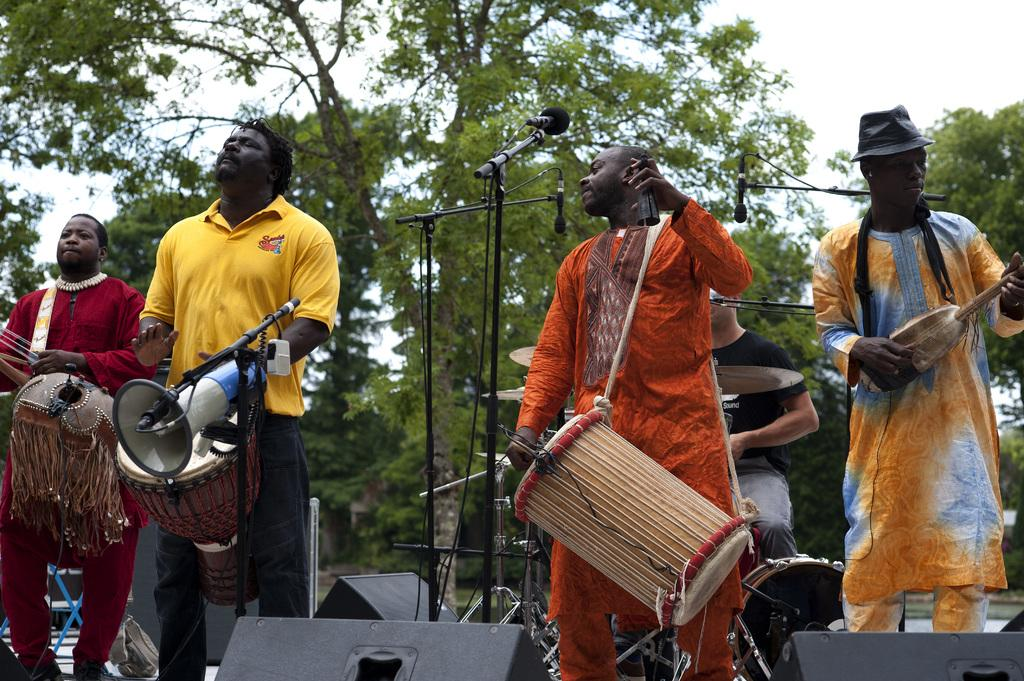How many people are performing in the image? There are 5 people in the image. What are the people doing on the stage? The people are playing musical instruments. What can be seen in the background of the image? There is a big tree and the sky visible in the background. What type of sack is being used by the people on stage? There is no sack present in the image; the people are playing musical instruments. What news event is being reported on stage? There is no news event being reported in the image; the people are playing musical instruments. 